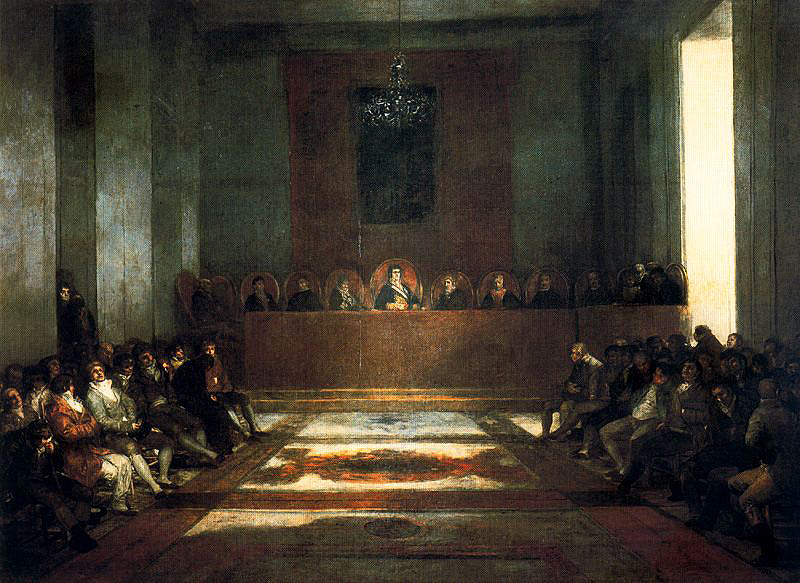Write a detailed description of the given image. The image portrays a deeply solemn religious assembly within a large hall, flatly lit except for a striking ray of light illuminating the central area. The floor features a colorful carpet with elaborate geometric patterns, contrasting with the austere surroundings. High above, a modest chandelier casts a gentle glow. The historical garments and decor suggest the scene might be set in the 17th or 18th century, indicative of a significant religious or political event. Figures in the background are seated in a semi-circular arrangement on a raised platform, dressed in traditional religious robes and appear to be leaders or important participants, engaging the attention of those seated below who are a mix of ordinary individuals and officials, their expressions ranging from introspective to attentive. The artist has skillfully rendered the interplay of light and shadow, drawing viewers' eyes towards the central figure, who appears to be addressing the assembly. 